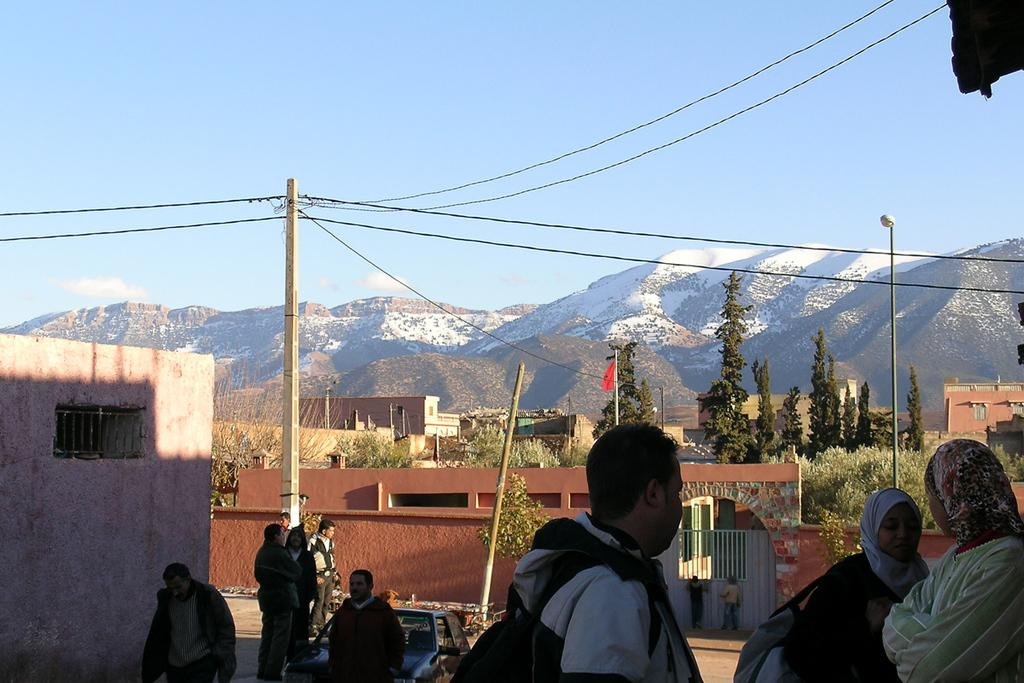How many people can be seen in the image? There are people in the image, but the exact number is not specified. What type of vehicle is present in the image? There is a car in the image. What is the setting of the image? The image features a road, trees, poles, wires, mountains, and a blue sky. What is the color of the sky in the image? The sky is blue in color. Where is the map located in the image? There is no map present in the image. What type of coal can be seen in the image? There is no coal present in the image. 